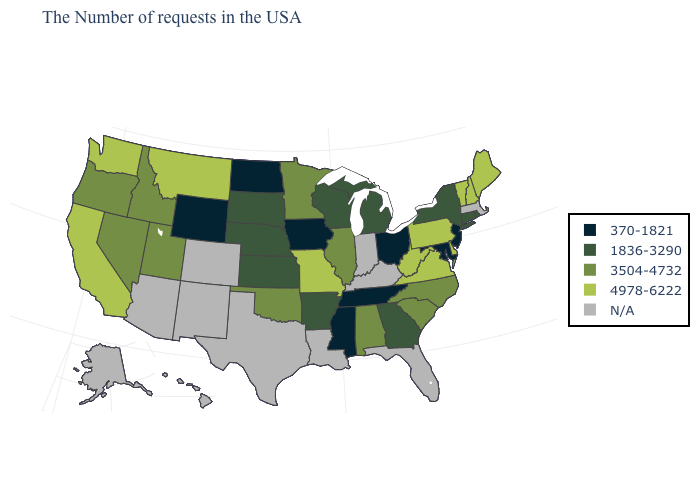What is the highest value in the USA?
Answer briefly. 4978-6222. Among the states that border Idaho , which have the lowest value?
Give a very brief answer. Wyoming. What is the value of Louisiana?
Short answer required. N/A. Name the states that have a value in the range 4978-6222?
Keep it brief. Maine, New Hampshire, Vermont, Delaware, Pennsylvania, Virginia, West Virginia, Missouri, Montana, California, Washington. What is the value of South Carolina?
Quick response, please. 3504-4732. Which states have the lowest value in the South?
Quick response, please. Maryland, Tennessee, Mississippi. What is the value of Rhode Island?
Quick response, please. 1836-3290. Name the states that have a value in the range 370-1821?
Short answer required. New Jersey, Maryland, Ohio, Tennessee, Mississippi, Iowa, North Dakota, Wyoming. Which states have the lowest value in the USA?
Be succinct. New Jersey, Maryland, Ohio, Tennessee, Mississippi, Iowa, North Dakota, Wyoming. Name the states that have a value in the range 4978-6222?
Keep it brief. Maine, New Hampshire, Vermont, Delaware, Pennsylvania, Virginia, West Virginia, Missouri, Montana, California, Washington. What is the value of Massachusetts?
Quick response, please. N/A. How many symbols are there in the legend?
Short answer required. 5. What is the lowest value in states that border Michigan?
Keep it brief. 370-1821. 